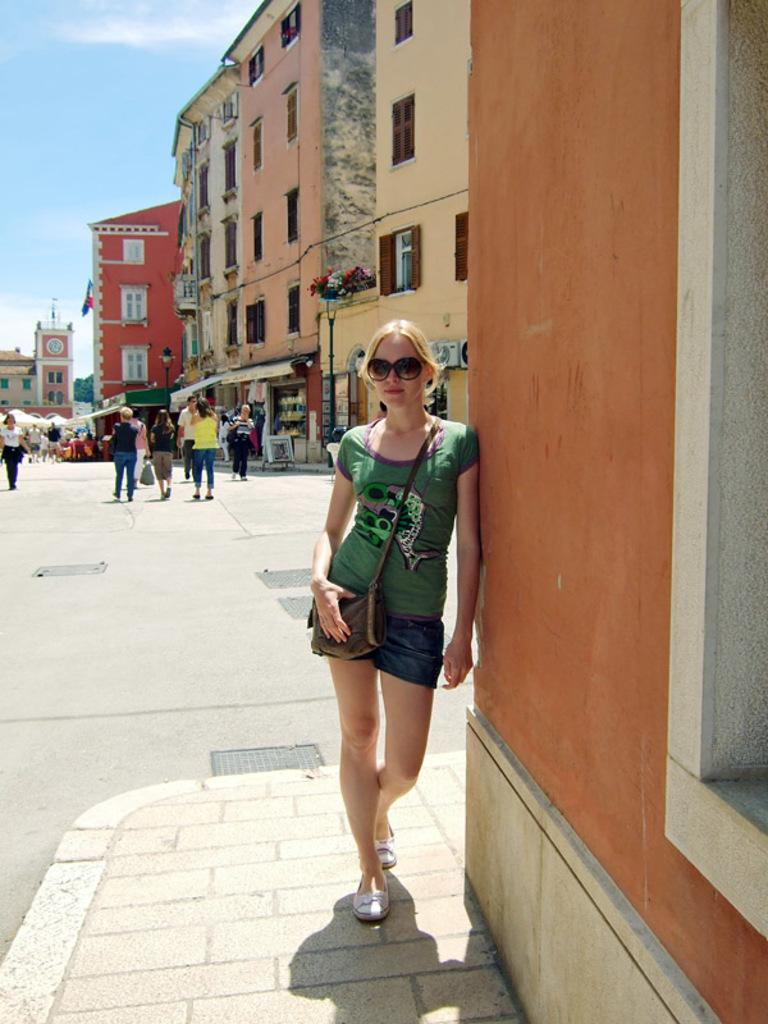What is the person in the image carrying? The person in the image is carrying a bag. What can be seen in the background of the image? There is a road, buildings, and sky visible in the image. What are the people on the road doing? The people on the road are walking. Can you describe the flag in the image? There is a flag in the image, but no specific details about its design or color are provided. How many hands are visible holding the bag in the image? The provided facts do not mention the number of hands holding the bag, only that a person is carrying a bag. --- Facts: 1. There is a person sitting on a chair in the image. 2. The person is holding a book. 3. There is a table in the image. 4. There is a lamp on the table. 5. The background of the image is a room. Absurd Topics: fish, ocean, waves Conversation: What is the person in the image doing? The person in the image is sitting on a chair and holding a book. What object can be seen on the table in the image? There is a lamp on the table in the image. What is the setting of the image? The background of the image is a room. Reasoning: Let's think step by step in order to produce the conversation. We start by identifying the main subject in the image, which is the person sitting on a chair and holding a book. Then, we expand the conversation to include other elements of the image, such as the table and lamp. Each question is designed to elicit a specific detail about the image that is known from the provided facts. Absurd Question/Answer: Can you see any fish or ocean waves in the image? No, there are no fish or ocean waves present in the image; the background is a room. 